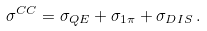Convert formula to latex. <formula><loc_0><loc_0><loc_500><loc_500>\sigma ^ { C C } = \sigma _ { Q E } + \sigma _ { 1 \pi } + \sigma _ { D I S } \, .</formula> 